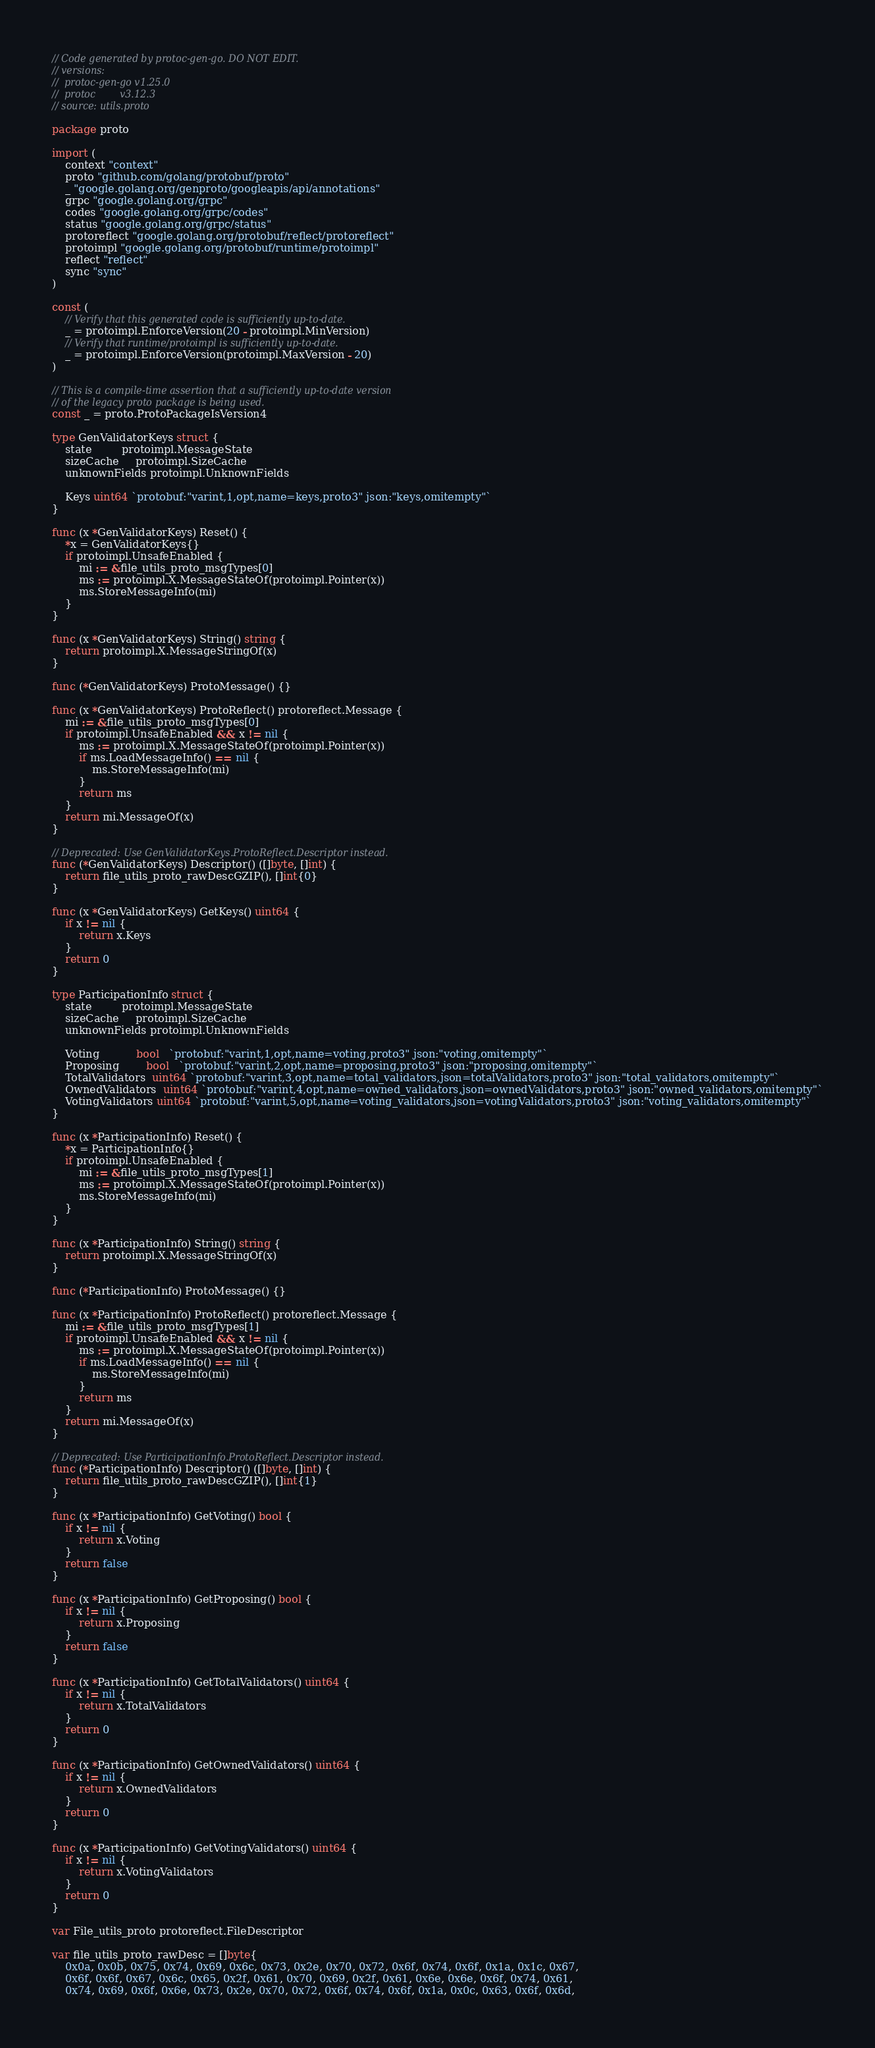Convert code to text. <code><loc_0><loc_0><loc_500><loc_500><_Go_>// Code generated by protoc-gen-go. DO NOT EDIT.
// versions:
// 	protoc-gen-go v1.25.0
// 	protoc        v3.12.3
// source: utils.proto

package proto

import (
	context "context"
	proto "github.com/golang/protobuf/proto"
	_ "google.golang.org/genproto/googleapis/api/annotations"
	grpc "google.golang.org/grpc"
	codes "google.golang.org/grpc/codes"
	status "google.golang.org/grpc/status"
	protoreflect "google.golang.org/protobuf/reflect/protoreflect"
	protoimpl "google.golang.org/protobuf/runtime/protoimpl"
	reflect "reflect"
	sync "sync"
)

const (
	// Verify that this generated code is sufficiently up-to-date.
	_ = protoimpl.EnforceVersion(20 - protoimpl.MinVersion)
	// Verify that runtime/protoimpl is sufficiently up-to-date.
	_ = protoimpl.EnforceVersion(protoimpl.MaxVersion - 20)
)

// This is a compile-time assertion that a sufficiently up-to-date version
// of the legacy proto package is being used.
const _ = proto.ProtoPackageIsVersion4

type GenValidatorKeys struct {
	state         protoimpl.MessageState
	sizeCache     protoimpl.SizeCache
	unknownFields protoimpl.UnknownFields

	Keys uint64 `protobuf:"varint,1,opt,name=keys,proto3" json:"keys,omitempty"`
}

func (x *GenValidatorKeys) Reset() {
	*x = GenValidatorKeys{}
	if protoimpl.UnsafeEnabled {
		mi := &file_utils_proto_msgTypes[0]
		ms := protoimpl.X.MessageStateOf(protoimpl.Pointer(x))
		ms.StoreMessageInfo(mi)
	}
}

func (x *GenValidatorKeys) String() string {
	return protoimpl.X.MessageStringOf(x)
}

func (*GenValidatorKeys) ProtoMessage() {}

func (x *GenValidatorKeys) ProtoReflect() protoreflect.Message {
	mi := &file_utils_proto_msgTypes[0]
	if protoimpl.UnsafeEnabled && x != nil {
		ms := protoimpl.X.MessageStateOf(protoimpl.Pointer(x))
		if ms.LoadMessageInfo() == nil {
			ms.StoreMessageInfo(mi)
		}
		return ms
	}
	return mi.MessageOf(x)
}

// Deprecated: Use GenValidatorKeys.ProtoReflect.Descriptor instead.
func (*GenValidatorKeys) Descriptor() ([]byte, []int) {
	return file_utils_proto_rawDescGZIP(), []int{0}
}

func (x *GenValidatorKeys) GetKeys() uint64 {
	if x != nil {
		return x.Keys
	}
	return 0
}

type ParticipationInfo struct {
	state         protoimpl.MessageState
	sizeCache     protoimpl.SizeCache
	unknownFields protoimpl.UnknownFields

	Voting           bool   `protobuf:"varint,1,opt,name=voting,proto3" json:"voting,omitempty"`
	Proposing        bool   `protobuf:"varint,2,opt,name=proposing,proto3" json:"proposing,omitempty"`
	TotalValidators  uint64 `protobuf:"varint,3,opt,name=total_validators,json=totalValidators,proto3" json:"total_validators,omitempty"`
	OwnedValidators  uint64 `protobuf:"varint,4,opt,name=owned_validators,json=ownedValidators,proto3" json:"owned_validators,omitempty"`
	VotingValidators uint64 `protobuf:"varint,5,opt,name=voting_validators,json=votingValidators,proto3" json:"voting_validators,omitempty"`
}

func (x *ParticipationInfo) Reset() {
	*x = ParticipationInfo{}
	if protoimpl.UnsafeEnabled {
		mi := &file_utils_proto_msgTypes[1]
		ms := protoimpl.X.MessageStateOf(protoimpl.Pointer(x))
		ms.StoreMessageInfo(mi)
	}
}

func (x *ParticipationInfo) String() string {
	return protoimpl.X.MessageStringOf(x)
}

func (*ParticipationInfo) ProtoMessage() {}

func (x *ParticipationInfo) ProtoReflect() protoreflect.Message {
	mi := &file_utils_proto_msgTypes[1]
	if protoimpl.UnsafeEnabled && x != nil {
		ms := protoimpl.X.MessageStateOf(protoimpl.Pointer(x))
		if ms.LoadMessageInfo() == nil {
			ms.StoreMessageInfo(mi)
		}
		return ms
	}
	return mi.MessageOf(x)
}

// Deprecated: Use ParticipationInfo.ProtoReflect.Descriptor instead.
func (*ParticipationInfo) Descriptor() ([]byte, []int) {
	return file_utils_proto_rawDescGZIP(), []int{1}
}

func (x *ParticipationInfo) GetVoting() bool {
	if x != nil {
		return x.Voting
	}
	return false
}

func (x *ParticipationInfo) GetProposing() bool {
	if x != nil {
		return x.Proposing
	}
	return false
}

func (x *ParticipationInfo) GetTotalValidators() uint64 {
	if x != nil {
		return x.TotalValidators
	}
	return 0
}

func (x *ParticipationInfo) GetOwnedValidators() uint64 {
	if x != nil {
		return x.OwnedValidators
	}
	return 0
}

func (x *ParticipationInfo) GetVotingValidators() uint64 {
	if x != nil {
		return x.VotingValidators
	}
	return 0
}

var File_utils_proto protoreflect.FileDescriptor

var file_utils_proto_rawDesc = []byte{
	0x0a, 0x0b, 0x75, 0x74, 0x69, 0x6c, 0x73, 0x2e, 0x70, 0x72, 0x6f, 0x74, 0x6f, 0x1a, 0x1c, 0x67,
	0x6f, 0x6f, 0x67, 0x6c, 0x65, 0x2f, 0x61, 0x70, 0x69, 0x2f, 0x61, 0x6e, 0x6e, 0x6f, 0x74, 0x61,
	0x74, 0x69, 0x6f, 0x6e, 0x73, 0x2e, 0x70, 0x72, 0x6f, 0x74, 0x6f, 0x1a, 0x0c, 0x63, 0x6f, 0x6d,</code> 